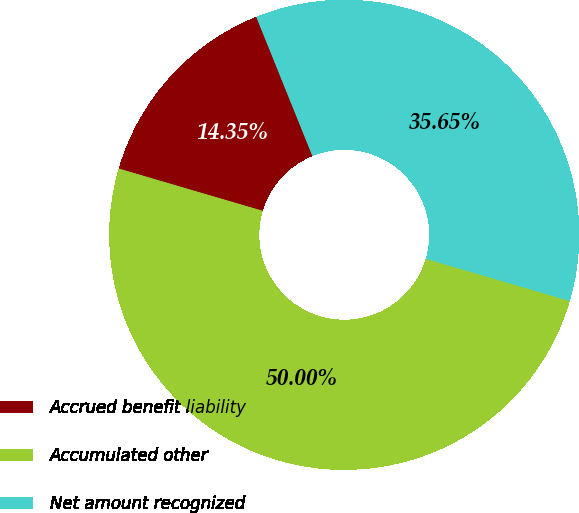Convert chart. <chart><loc_0><loc_0><loc_500><loc_500><pie_chart><fcel>Accrued benefit liability<fcel>Accumulated other<fcel>Net amount recognized<nl><fcel>14.35%<fcel>50.0%<fcel>35.65%<nl></chart> 